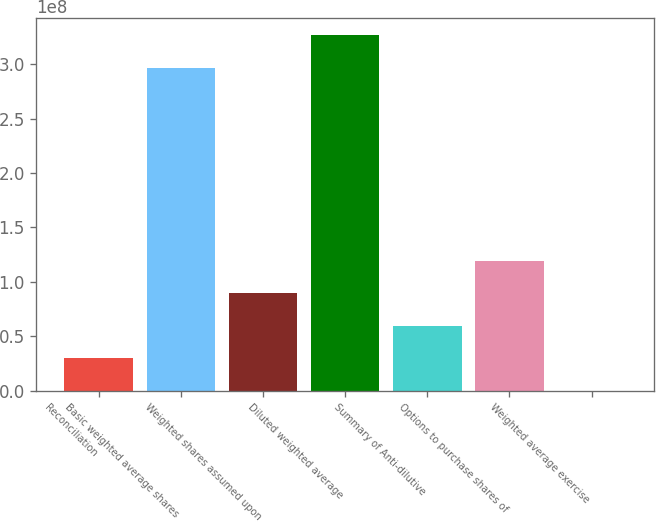<chart> <loc_0><loc_0><loc_500><loc_500><bar_chart><fcel>Reconciliation<fcel>Basic weighted average shares<fcel>Weighted shares assumed upon<fcel>Diluted weighted average<fcel>Summary of Anti-dilutive<fcel>Options to purchase shares of<fcel>Weighted average exercise<nl><fcel>2.97684e+07<fcel>2.96754e+08<fcel>8.93051e+07<fcel>3.26523e+08<fcel>5.95368e+07<fcel>1.19073e+08<fcel>54<nl></chart> 